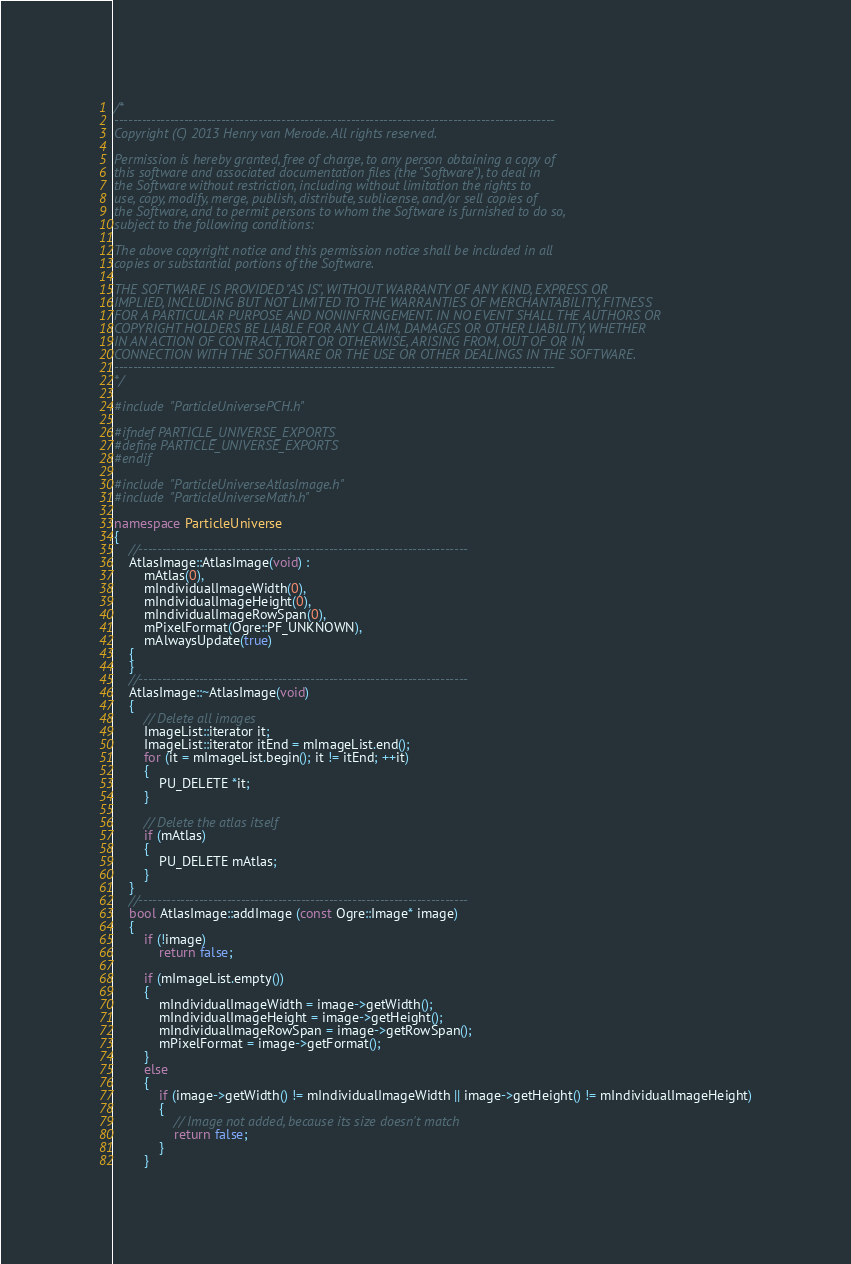Convert code to text. <code><loc_0><loc_0><loc_500><loc_500><_C++_>/*
-----------------------------------------------------------------------------------------------
Copyright (C) 2013 Henry van Merode. All rights reserved.

Permission is hereby granted, free of charge, to any person obtaining a copy of
this software and associated documentation files (the "Software"), to deal in
the Software without restriction, including without limitation the rights to
use, copy, modify, merge, publish, distribute, sublicense, and/or sell copies of
the Software, and to permit persons to whom the Software is furnished to do so,
subject to the following conditions:

The above copyright notice and this permission notice shall be included in all
copies or substantial portions of the Software.

THE SOFTWARE IS PROVIDED "AS IS", WITHOUT WARRANTY OF ANY KIND, EXPRESS OR
IMPLIED, INCLUDING BUT NOT LIMITED TO THE WARRANTIES OF MERCHANTABILITY, FITNESS
FOR A PARTICULAR PURPOSE AND NONINFRINGEMENT. IN NO EVENT SHALL THE AUTHORS OR
COPYRIGHT HOLDERS BE LIABLE FOR ANY CLAIM, DAMAGES OR OTHER LIABILITY, WHETHER
IN AN ACTION OF CONTRACT, TORT OR OTHERWISE, ARISING FROM, OUT OF OR IN
CONNECTION WITH THE SOFTWARE OR THE USE OR OTHER DEALINGS IN THE SOFTWARE.
-----------------------------------------------------------------------------------------------
*/

#include "ParticleUniversePCH.h"

#ifndef PARTICLE_UNIVERSE_EXPORTS
#define PARTICLE_UNIVERSE_EXPORTS
#endif

#include "ParticleUniverseAtlasImage.h"
#include "ParticleUniverseMath.h"

namespace ParticleUniverse
{
	//-----------------------------------------------------------------------
	AtlasImage::AtlasImage(void) :
		mAtlas(0),
		mIndividualImageWidth(0),
		mIndividualImageHeight(0),
		mIndividualImageRowSpan(0),
		mPixelFormat(Ogre::PF_UNKNOWN),
		mAlwaysUpdate(true)
	{
	}
	//-----------------------------------------------------------------------
	AtlasImage::~AtlasImage(void)
	{
		// Delete all images
		ImageList::iterator it;
		ImageList::iterator itEnd = mImageList.end();
		for (it = mImageList.begin(); it != itEnd; ++it)
		{
			PU_DELETE *it;
		}

		// Delete the atlas itself
		if (mAtlas)
		{
			PU_DELETE mAtlas;
		}
	}
	//-----------------------------------------------------------------------
	bool AtlasImage::addImage (const Ogre::Image* image)
	{
		if (!image)
			return false;

		if (mImageList.empty())
		{
			mIndividualImageWidth = image->getWidth();
			mIndividualImageHeight = image->getHeight();
			mIndividualImageRowSpan = image->getRowSpan();
			mPixelFormat = image->getFormat();
		}
		else
		{
			if (image->getWidth() != mIndividualImageWidth || image->getHeight() != mIndividualImageHeight)
			{
				// Image not added, because its size doesn't match
				return false;
			}
		}
</code> 